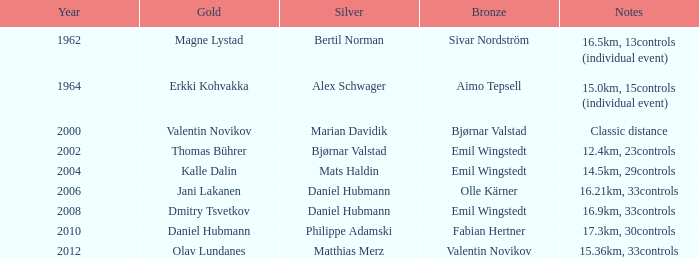WHAT IS THE SILVER WITH A YEAR OF 1962? Bertil Norman. 